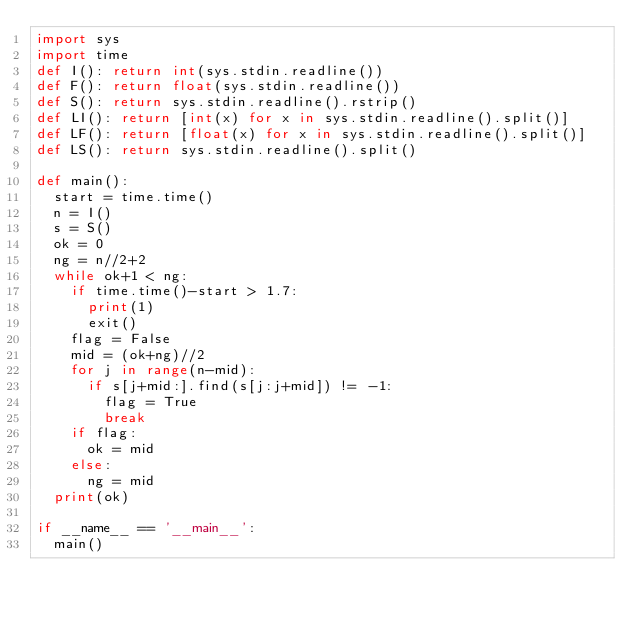Convert code to text. <code><loc_0><loc_0><loc_500><loc_500><_Python_>import sys
import time
def I(): return int(sys.stdin.readline())
def F(): return float(sys.stdin.readline())
def S(): return sys.stdin.readline().rstrip()
def LI(): return [int(x) for x in sys.stdin.readline().split()]
def LF(): return [float(x) for x in sys.stdin.readline().split()]
def LS(): return sys.stdin.readline().split()

def main():
  start = time.time()
  n = I()
  s = S()
  ok = 0
  ng = n//2+2
  while ok+1 < ng:
    if time.time()-start > 1.7:
      print(1)
      exit()
    flag = False
    mid = (ok+ng)//2
    for j in range(n-mid):
      if s[j+mid:].find(s[j:j+mid]) != -1:
        flag = True
        break
    if flag:
      ok = mid
    else:
      ng = mid
  print(ok)

if __name__ == '__main__':
  main()</code> 